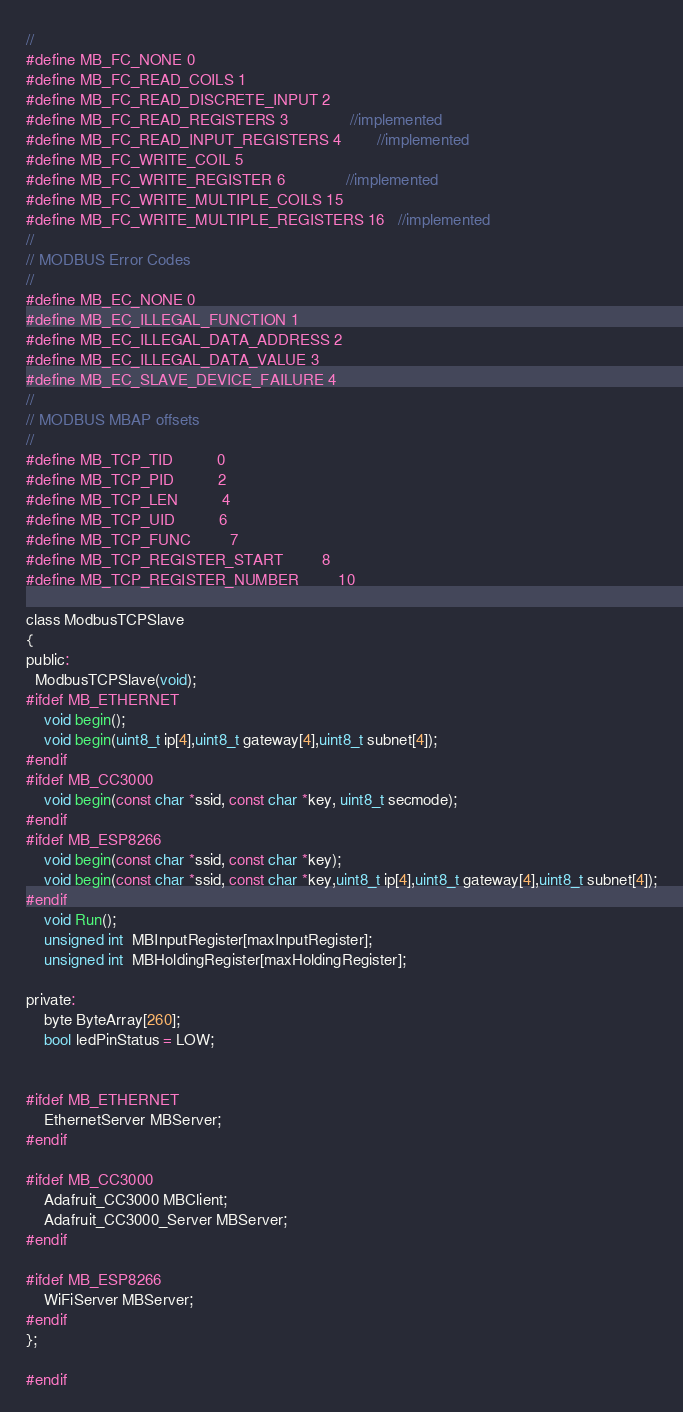<code> <loc_0><loc_0><loc_500><loc_500><_C_>//
#define MB_FC_NONE 0
#define MB_FC_READ_COILS 1
#define MB_FC_READ_DISCRETE_INPUT 2
#define MB_FC_READ_REGISTERS 3              //implemented
#define MB_FC_READ_INPUT_REGISTERS 4        //implemented
#define MB_FC_WRITE_COIL 5
#define MB_FC_WRITE_REGISTER 6              //implemented
#define MB_FC_WRITE_MULTIPLE_COILS 15
#define MB_FC_WRITE_MULTIPLE_REGISTERS 16   //implemented
//
// MODBUS Error Codes
//
#define MB_EC_NONE 0
#define MB_EC_ILLEGAL_FUNCTION 1
#define MB_EC_ILLEGAL_DATA_ADDRESS 2
#define MB_EC_ILLEGAL_DATA_VALUE 3
#define MB_EC_SLAVE_DEVICE_FAILURE 4
//
// MODBUS MBAP offsets
//
#define MB_TCP_TID          0
#define MB_TCP_PID          2
#define MB_TCP_LEN          4
#define MB_TCP_UID          6
#define MB_TCP_FUNC         7
#define MB_TCP_REGISTER_START         8
#define MB_TCP_REGISTER_NUMBER         10

class ModbusTCPSlave
{
public:
  ModbusTCPSlave(void);
#ifdef MB_ETHERNET
    void begin();
    void begin(uint8_t ip[4],uint8_t gateway[4],uint8_t subnet[4]);
#endif
#ifdef MB_CC3000
    void begin(const char *ssid, const char *key, uint8_t secmode);
#endif
#ifdef MB_ESP8266
    void begin(const char *ssid, const char *key);
    void begin(const char *ssid, const char *key,uint8_t ip[4],uint8_t gateway[4],uint8_t subnet[4]);
#endif
    void Run();
    unsigned int  MBInputRegister[maxInputRegister];
    unsigned int  MBHoldingRegister[maxHoldingRegister];

private: 
    byte ByteArray[260];
    bool ledPinStatus = LOW;
    
    
#ifdef MB_ETHERNET
    EthernetServer MBServer;
#endif
    
#ifdef MB_CC3000
    Adafruit_CC3000 MBClient;
    Adafruit_CC3000_Server MBServer;
#endif
    
#ifdef MB_ESP8266
    WiFiServer MBServer;
#endif
};

#endif
</code> 